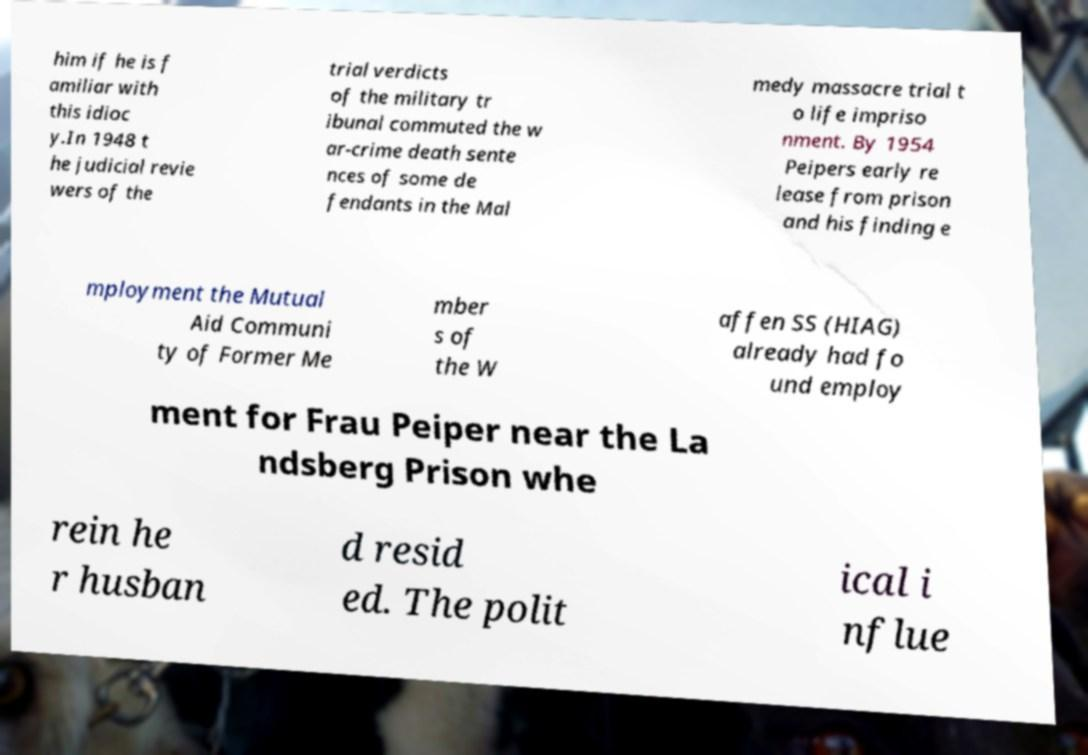There's text embedded in this image that I need extracted. Can you transcribe it verbatim? him if he is f amiliar with this idioc y.In 1948 t he judicial revie wers of the trial verdicts of the military tr ibunal commuted the w ar-crime death sente nces of some de fendants in the Mal medy massacre trial t o life impriso nment. By 1954 Peipers early re lease from prison and his finding e mployment the Mutual Aid Communi ty of Former Me mber s of the W affen SS (HIAG) already had fo und employ ment for Frau Peiper near the La ndsberg Prison whe rein he r husban d resid ed. The polit ical i nflue 